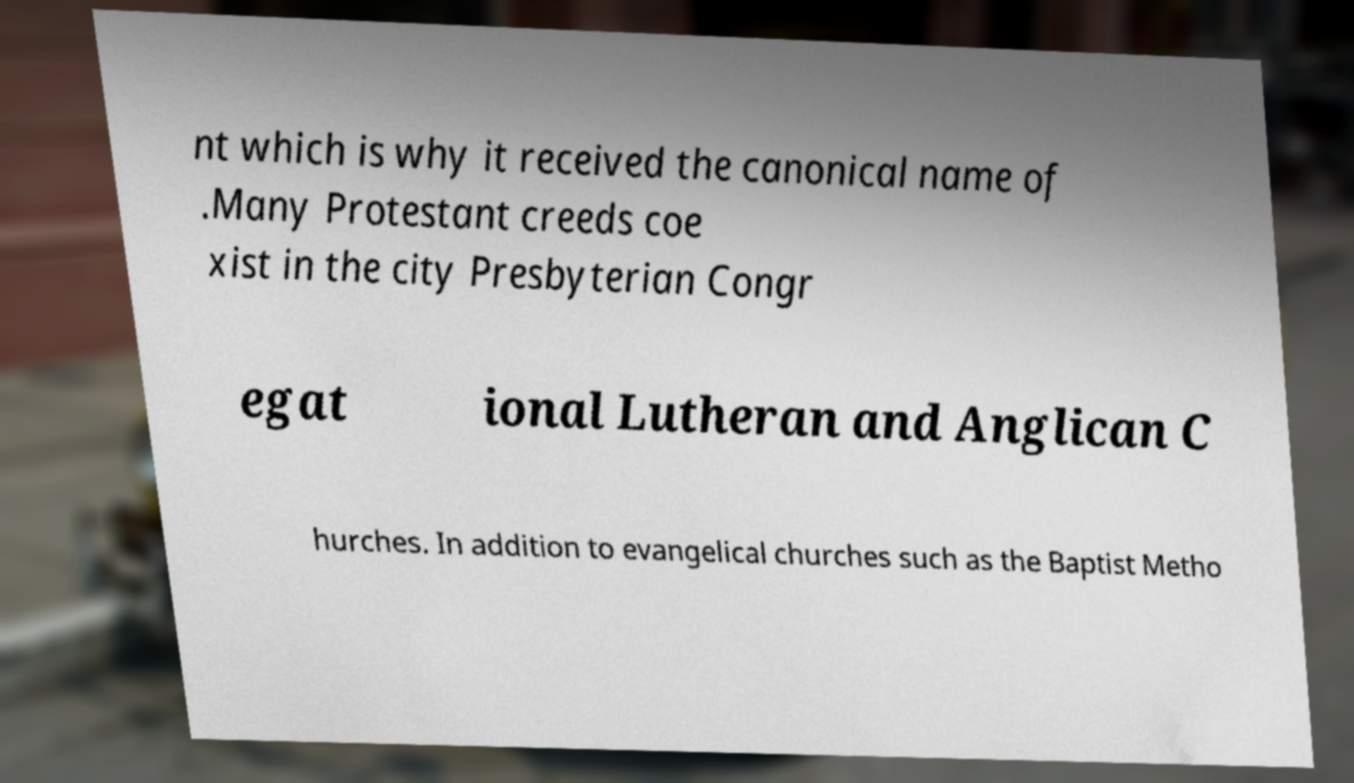I need the written content from this picture converted into text. Can you do that? nt which is why it received the canonical name of .Many Protestant creeds coe xist in the city Presbyterian Congr egat ional Lutheran and Anglican C hurches. In addition to evangelical churches such as the Baptist Metho 